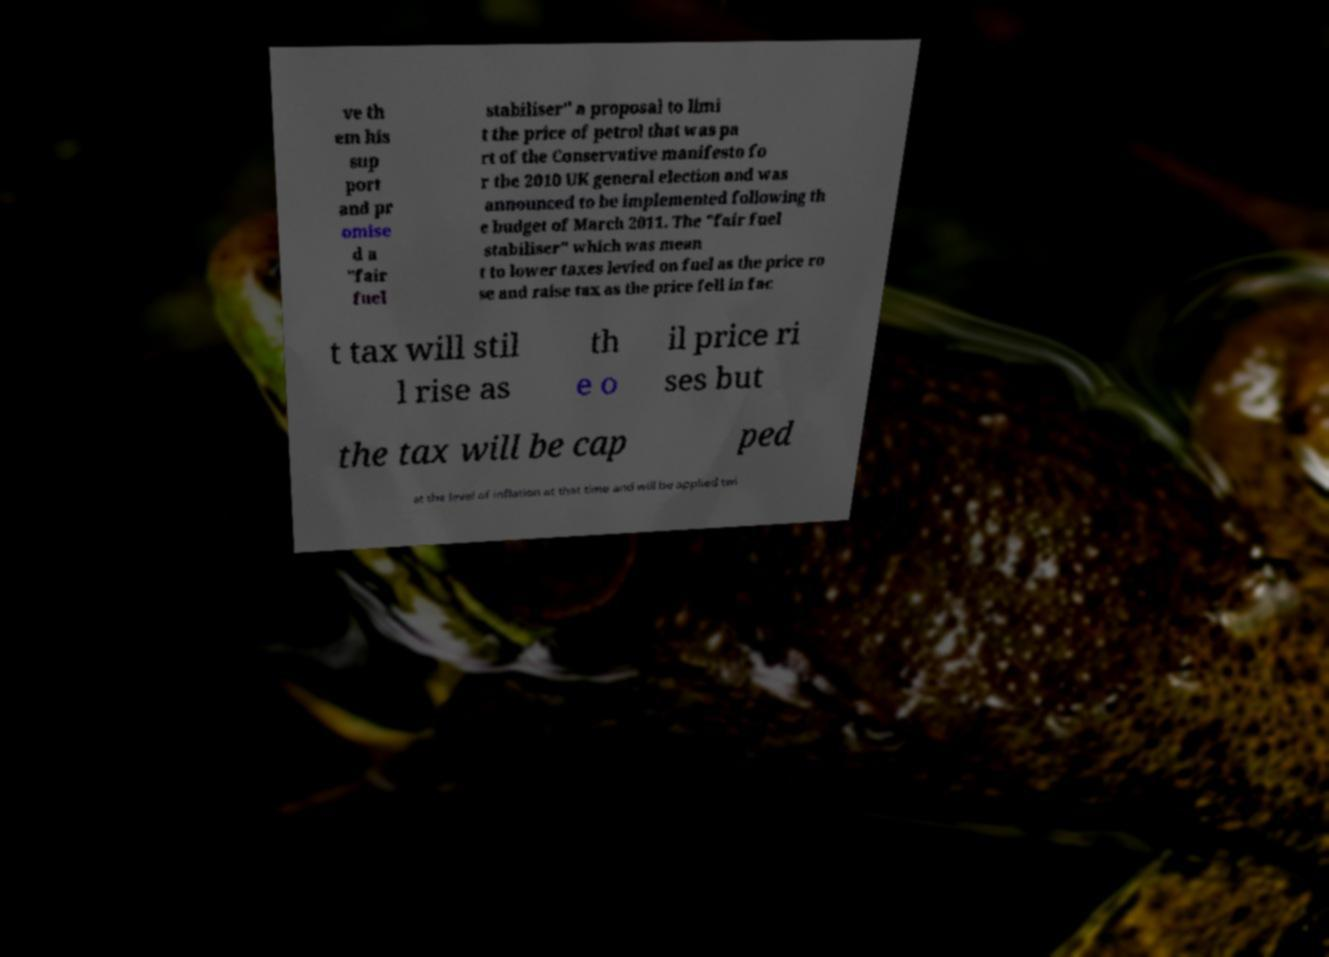Could you extract and type out the text from this image? ve th em his sup port and pr omise d a "fair fuel stabiliser" a proposal to limi t the price of petrol that was pa rt of the Conservative manifesto fo r the 2010 UK general election and was announced to be implemented following th e budget of March 2011. The "fair fuel stabiliser" which was mean t to lower taxes levied on fuel as the price ro se and raise tax as the price fell in fac t tax will stil l rise as th e o il price ri ses but the tax will be cap ped at the level of inflation at that time and will be applied twi 